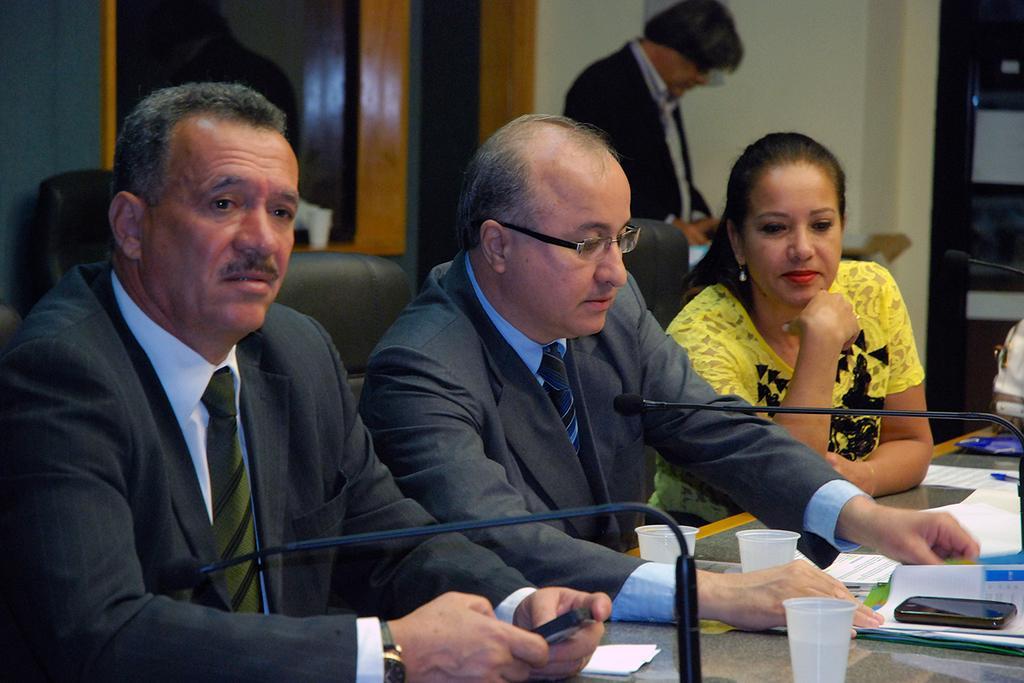Could you give a brief overview of what you see in this image? This picture describes about group of people few are seated on the chairs, in front of them we can see few microphones, glasses, papers, mobile and other things on the table, in the background we can see a man he is standing. 